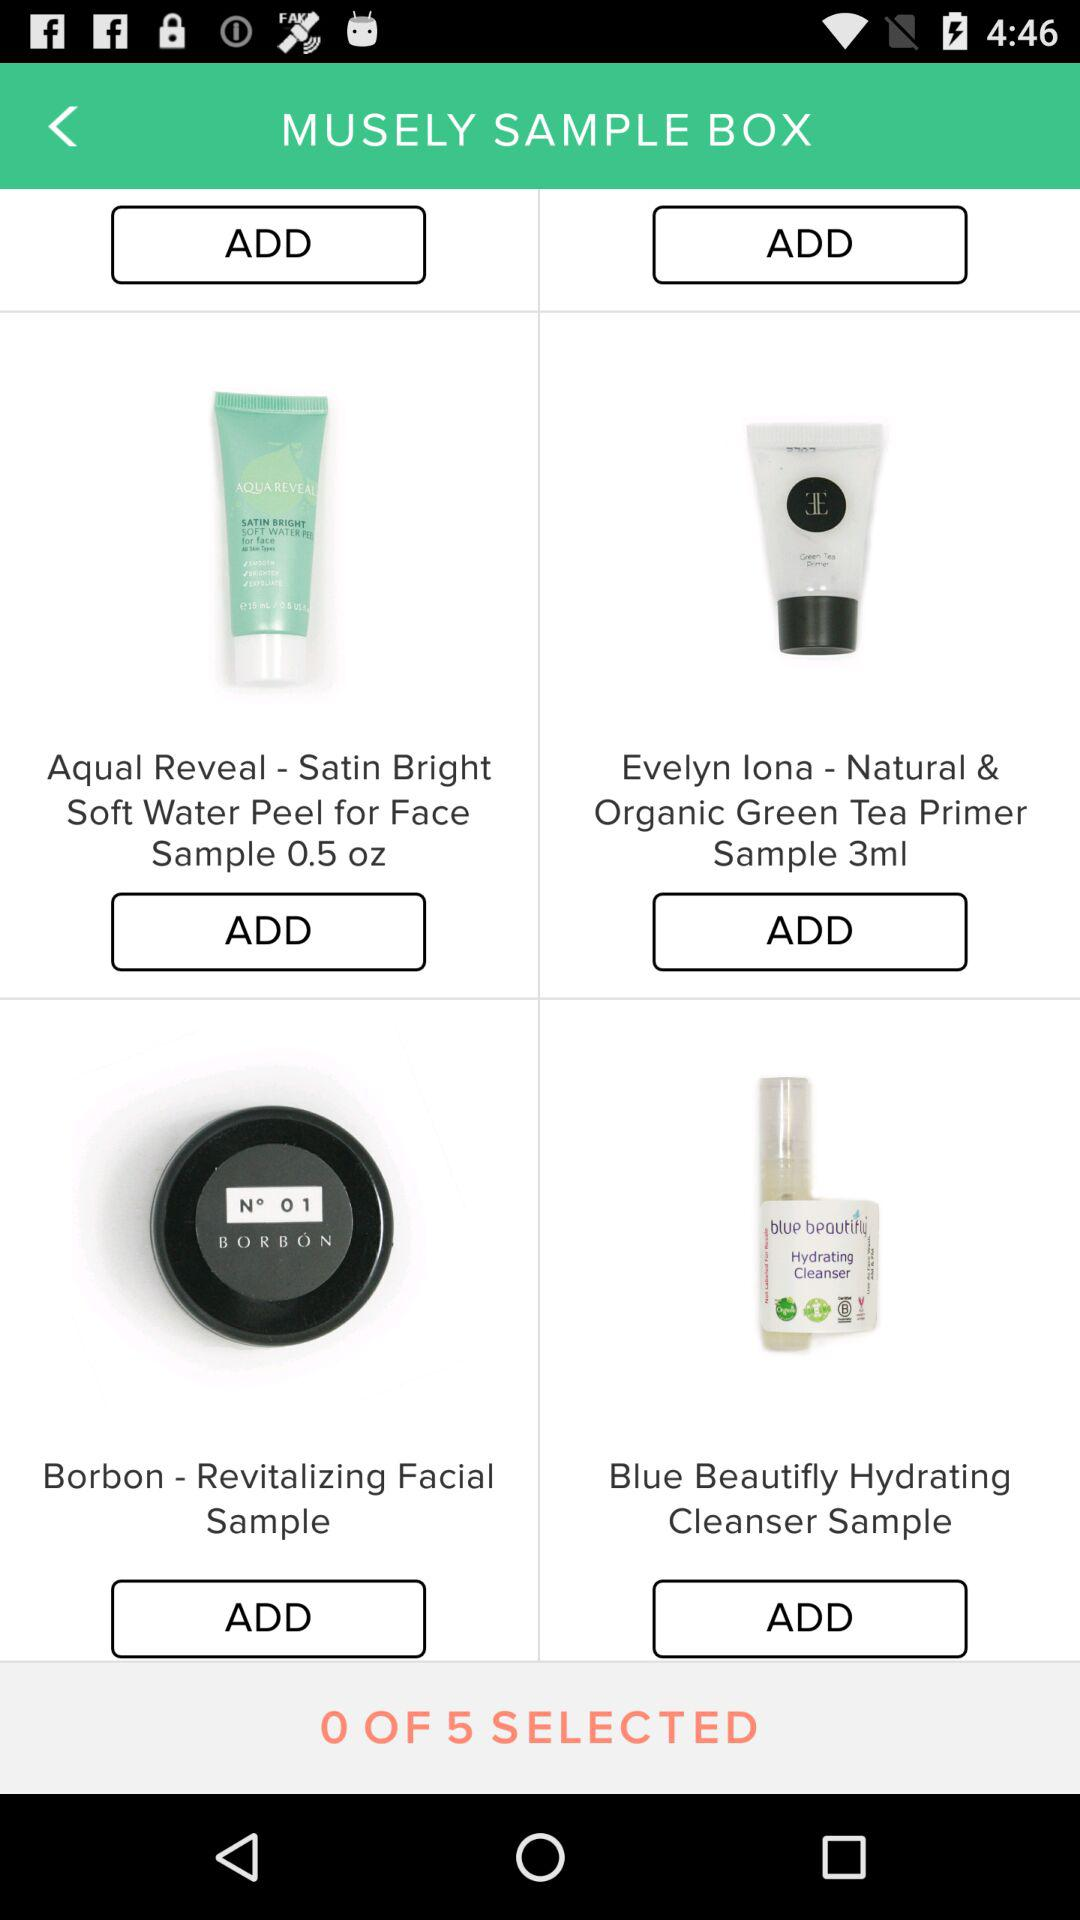How much is the quantity of the "Evelyn lona" item? The quantity of the "Evelyn lona" item is 3 ml. 